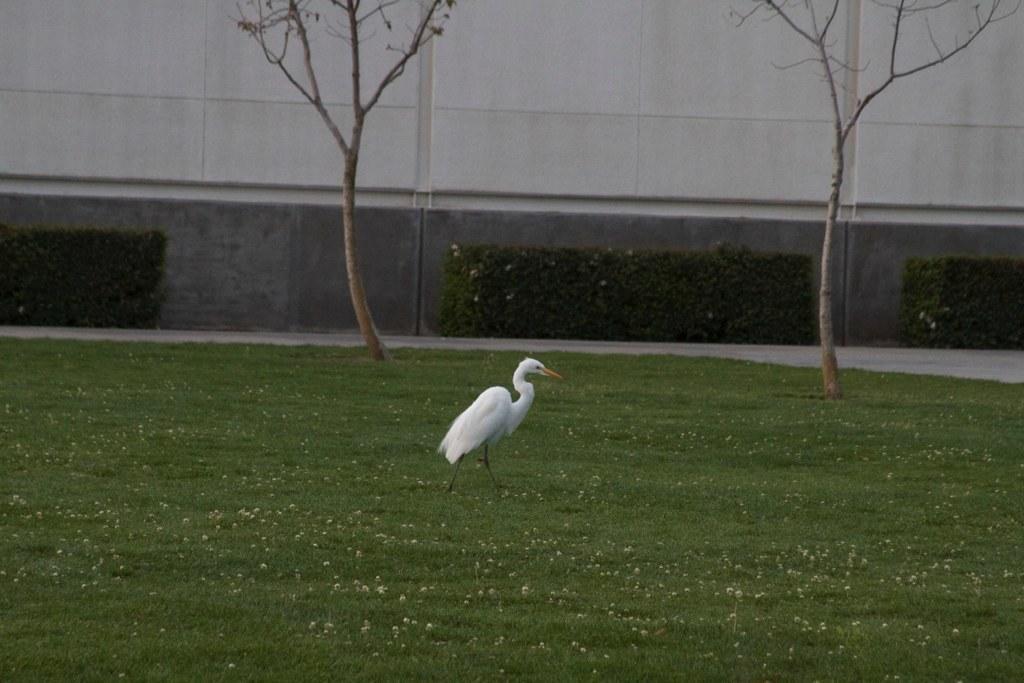In one or two sentences, can you explain what this image depicts? In the middle of this image there is a crane walking on the ground towards the right side. On the ground, I can see the grass. In the background there are two trees and a wall. 